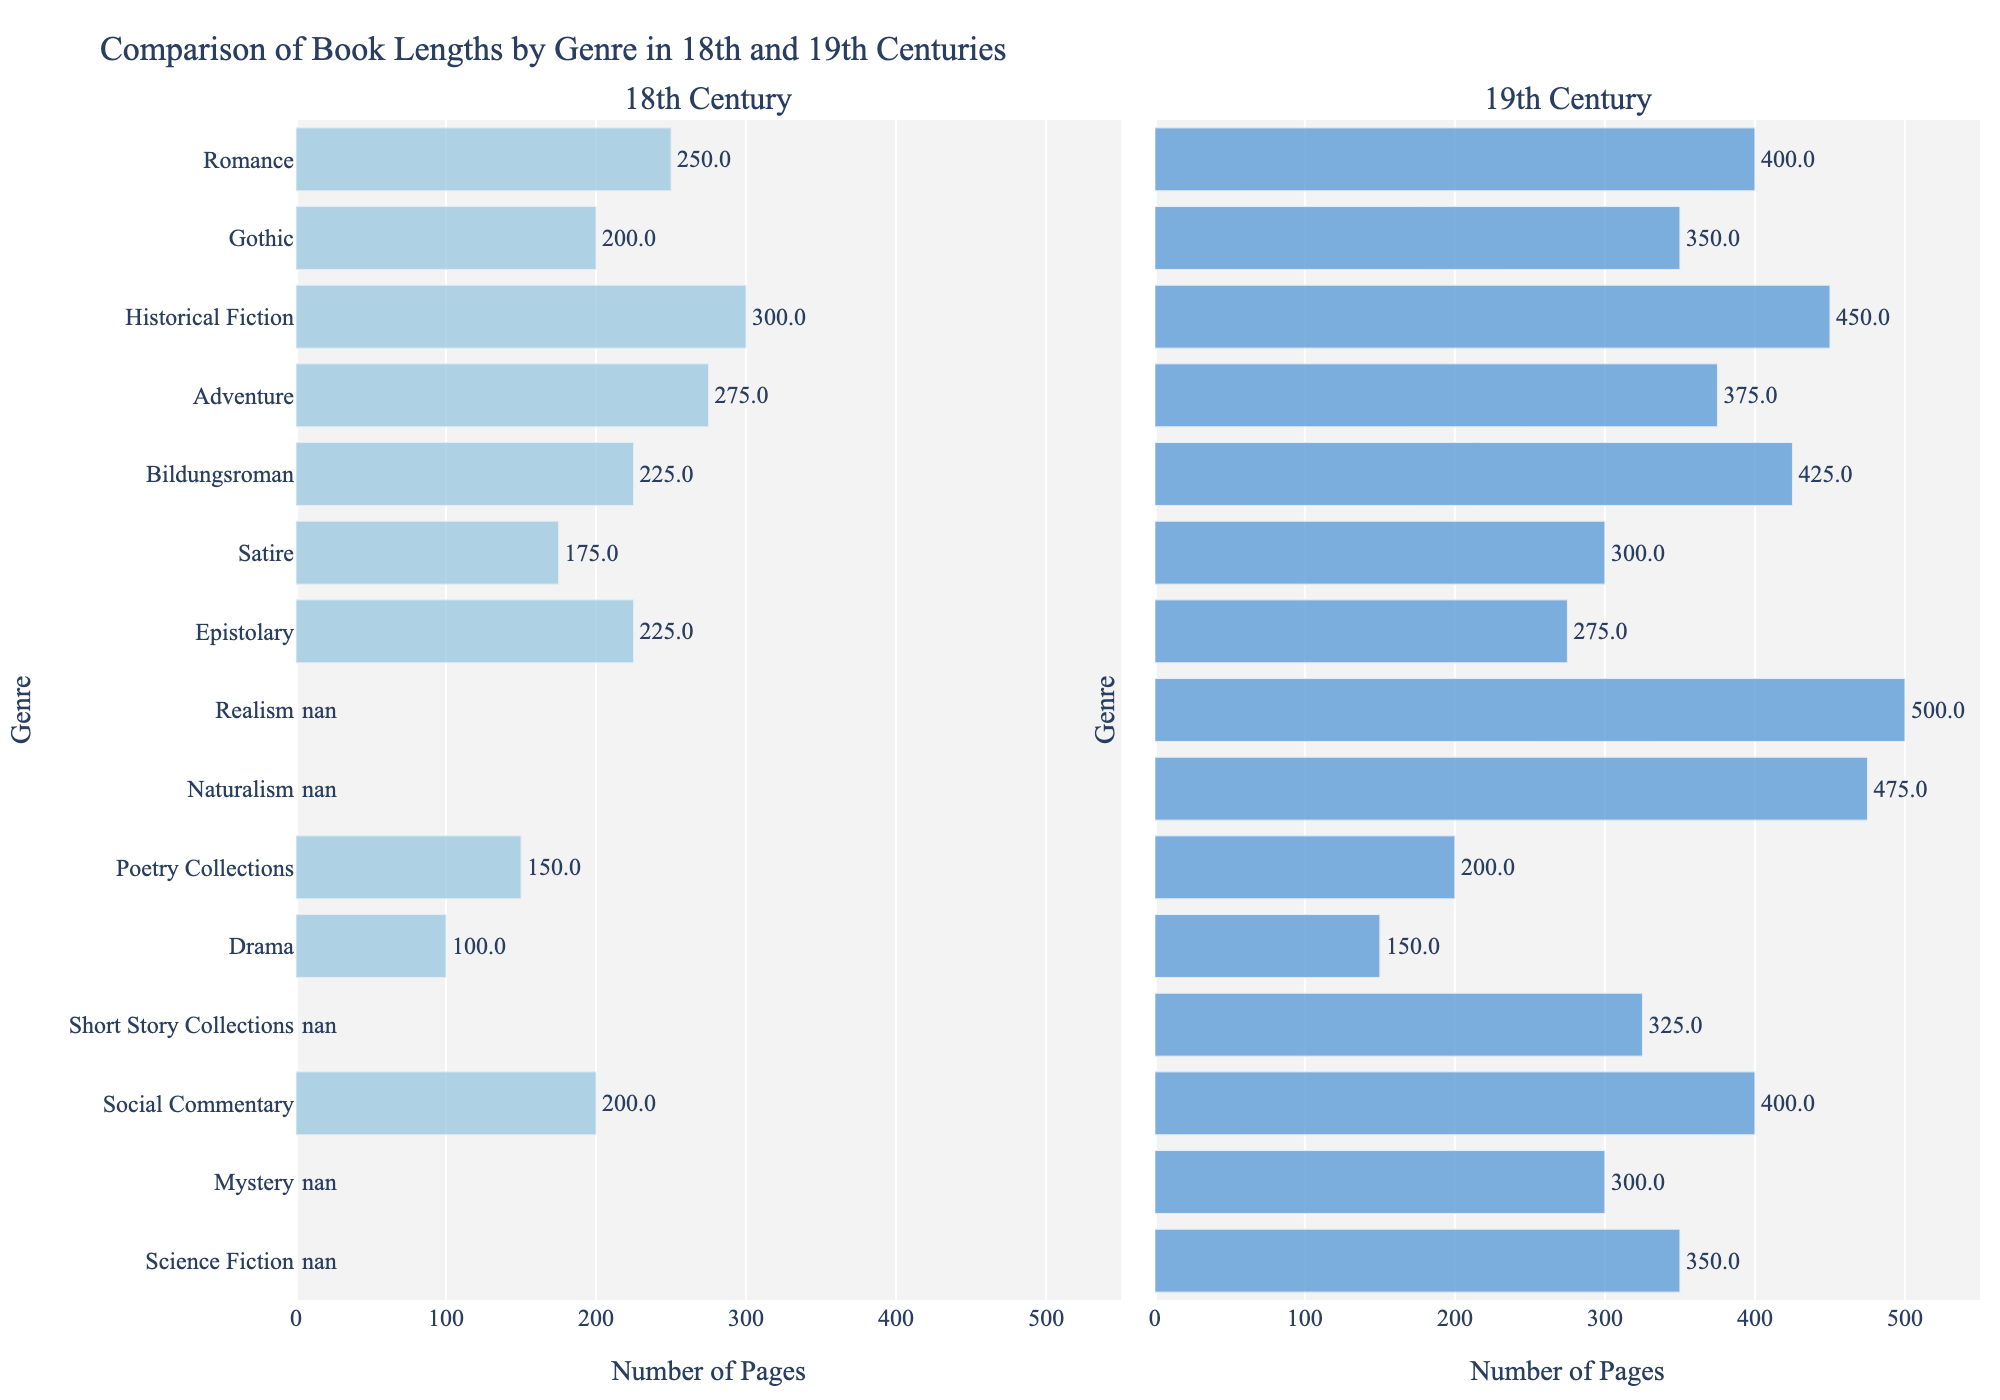What is the difference in book length for the genre 'Gothic' between the 18th and 19th centuries? To find the difference, subtract the 18th-century value (200 pages) from the 19th-century value (350 pages). 350 - 200 = 150
Answer: 150 Which genre experienced the largest increase in book length from the 18th to the 19th century? Compare the differences in book lengths for all genres available in both centuries. The largest increase is 225 pages in the genre 'Bildungsroman' (425 - 225 = 200).
Answer: Bildungsroman Which genre had the smallest average book length in the 18th century, and what was that average? To determine the smallest average, look at all the 18th-century values. The smallest value is 100 pages for the genre 'Drama'.
Answer: Drama, 100 What is the total number of pages for 'Romance' books in both centuries combined? Sum the book lengths for 'Romance' in the 18th century (250 pages) and the 19th century (400 pages). 250 + 400 = 650
Answer: 650 Which genre has the longest book length in the 19th century? Identify the highest value in the 19th-century column. The longest book length is 500 pages for the genre 'Realism'.
Answer: Realism Describe the color and length of the bars for the 'Poetry Collections' genre in both centuries. The 'Poetry Collections' genre bars are light blue in the 18th century and medium blue in the 19th century, with lengths indicating 150 and 200 pages respectively.
Answer: Light blue, 150; Medium blue, 200 How many more pages do 'Social Commentary' books have in the 19th century compared to the 18th century? Subtract the 18th-century value (200 pages) from the 19th-century value (400 pages). The difference is 400 - 200 = 200 pages.
Answer: 200 Which genre, among those present in both centuries, shows the least change in book length? Calculate the differences in lengths for each genre available in both centuries. 'Epistolary' has the smallest change with an increase of 50 pages (275 - 225 = 50).
Answer: Epistolary What is the average book length for all genres available in the 19th century but not in the 18th century? Sum the lengths for 'Realism' (500), 'Naturalism' (475), 'Short Story Collections' (325), 'Mystery' (300), and 'Science Fiction' (350), then divide by the number of genres (5). (500 + 475 + 325 + 300 + 350) / 5 = 390
Answer: 390 